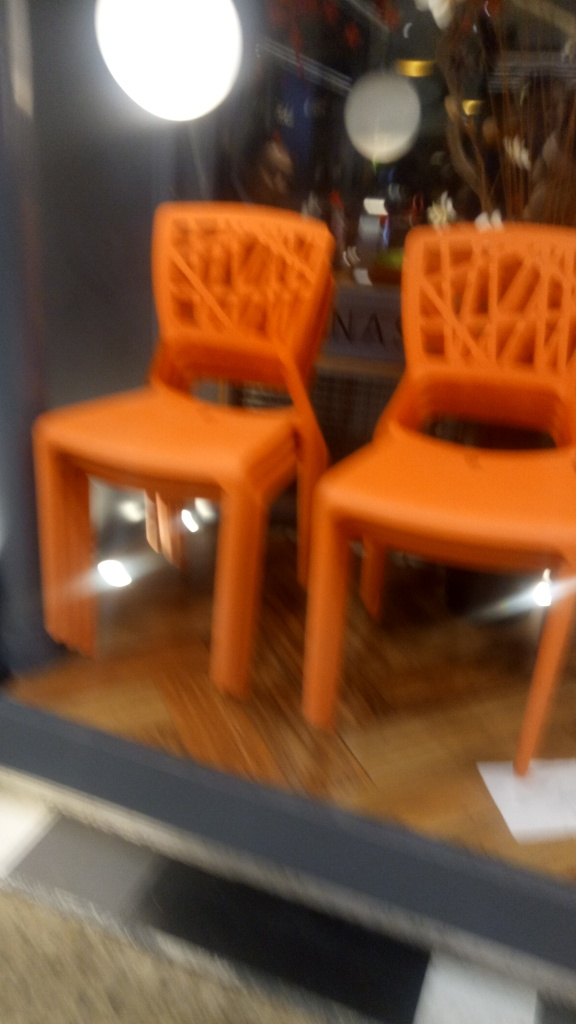Is the image properly focused? No, the image is not properly focused. The blurriness is evident across the entire photo, which obscures the details and sharpness that would be present in a focused image. 